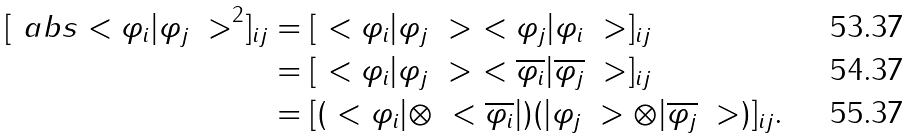Convert formula to latex. <formula><loc_0><loc_0><loc_500><loc_500>[ \ a b s { \ < \varphi _ { i } | \varphi _ { j } \ > } ^ { 2 } ] _ { i j } & = [ \ < \varphi _ { i } | \varphi _ { j } \ > \ < \varphi _ { j } | \varphi _ { i } \ > ] _ { i j } \\ & = [ \ < \varphi _ { i } | \varphi _ { j } \ > \ < \overline { \varphi _ { i } } | \overline { \varphi _ { j } } \ > ] _ { i j } \\ & = [ ( \ < \varphi _ { i } | \otimes \ < \overline { \varphi _ { i } } | ) ( | \varphi _ { j } \ > \otimes | \overline { \varphi _ { j } } \ > ) ] _ { i j } .</formula> 